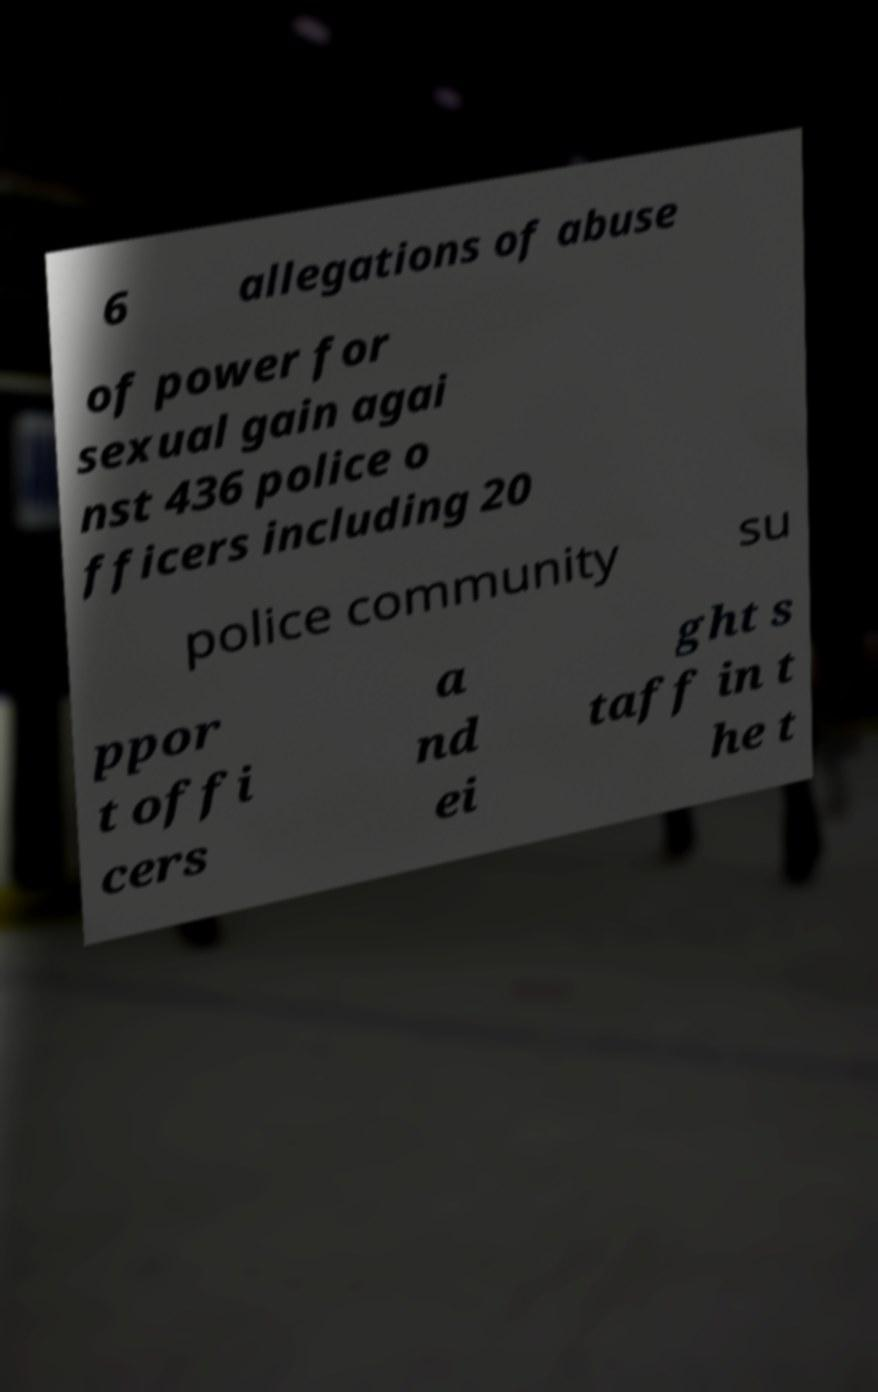For documentation purposes, I need the text within this image transcribed. Could you provide that? 6 allegations of abuse of power for sexual gain agai nst 436 police o fficers including 20 police community su ppor t offi cers a nd ei ght s taff in t he t 